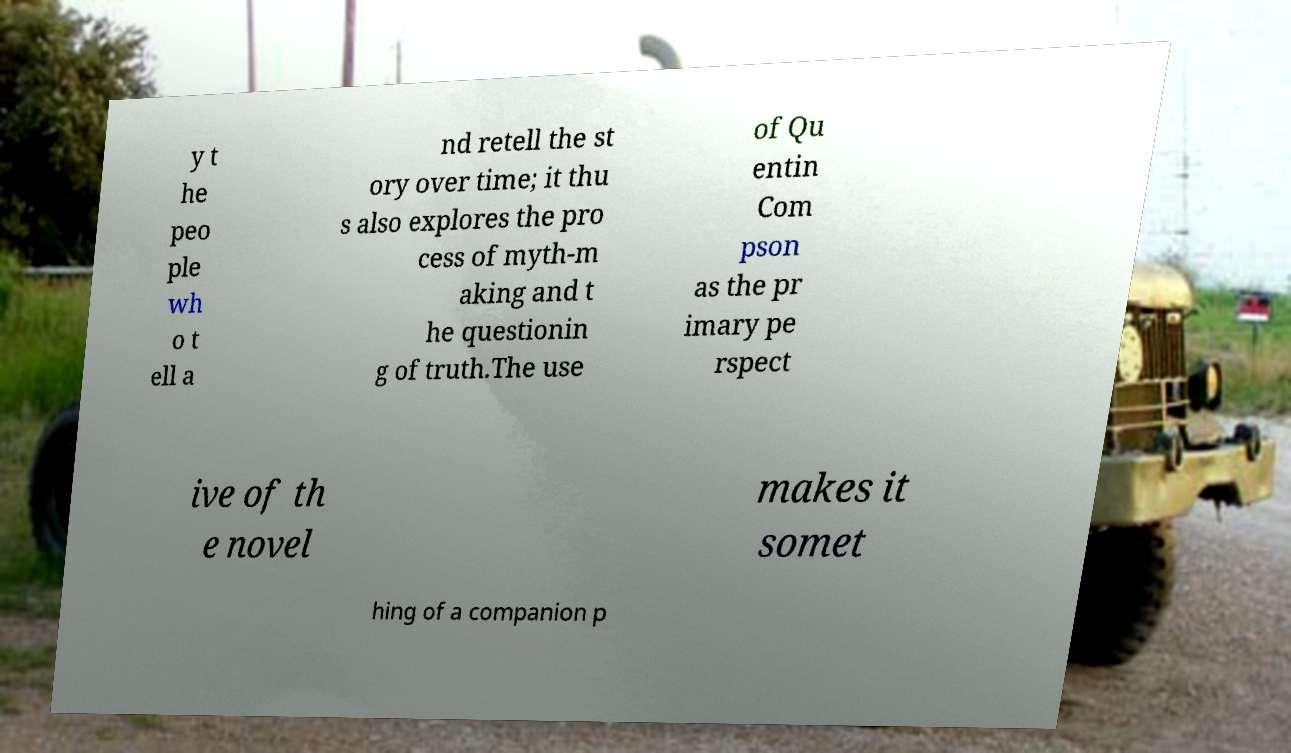Can you read and provide the text displayed in the image?This photo seems to have some interesting text. Can you extract and type it out for me? y t he peo ple wh o t ell a nd retell the st ory over time; it thu s also explores the pro cess of myth-m aking and t he questionin g of truth.The use of Qu entin Com pson as the pr imary pe rspect ive of th e novel makes it somet hing of a companion p 